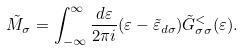Convert formula to latex. <formula><loc_0><loc_0><loc_500><loc_500>& \tilde { M } _ { \sigma } = \int ^ { \infty } _ { - \infty } \frac { d \varepsilon } { 2 \pi i } ( \varepsilon - \tilde { \varepsilon } _ { d \sigma } ) \tilde { G } ^ { < } _ { \sigma \sigma } ( \varepsilon ) .</formula> 